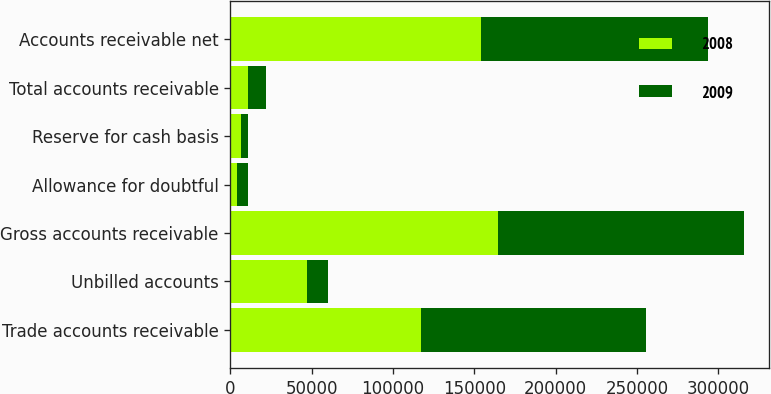Convert chart. <chart><loc_0><loc_0><loc_500><loc_500><stacked_bar_chart><ecel><fcel>Trade accounts receivable<fcel>Unbilled accounts<fcel>Gross accounts receivable<fcel>Allowance for doubtful<fcel>Reserve for cash basis<fcel>Total accounts receivable<fcel>Accounts receivable net<nl><fcel>2008<fcel>117449<fcel>47399<fcel>164848<fcel>4137<fcel>6442<fcel>10579<fcel>154269<nl><fcel>2009<fcel>138286<fcel>12596<fcel>150882<fcel>6943<fcel>4327<fcel>11270<fcel>139612<nl></chart> 